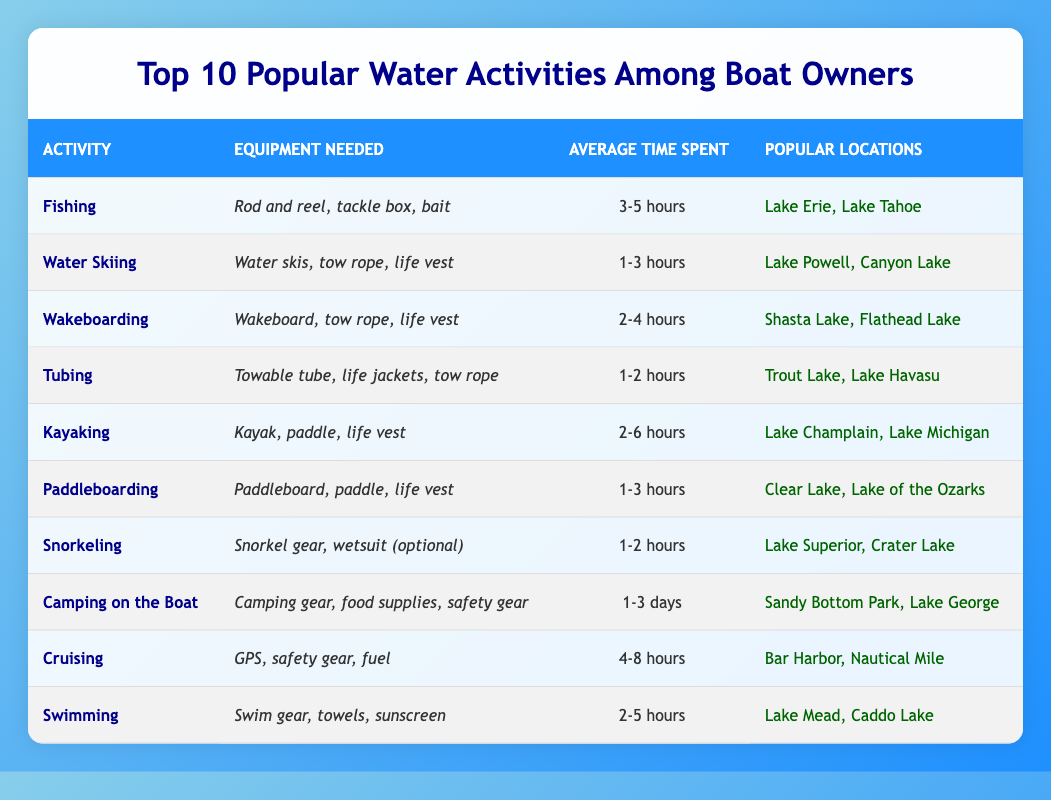What is the most time-consuming activity among boat owners? The table shows the average time spent for each activity. By comparing the values, "Camping on the Boat" has the longest average time spent of "1-3 days", making it the most time-consuming activity.
Answer: Camping on the Boat Which activity requires a towable tube? Looking at the "Equipment Needed" column, "Tubing" is the activity that specifically mentions requiring a "Towable tube".
Answer: Tubing How many activities have an average time spent of 1-3 hours? The activities listed with "average time spent" of 1-3 hours are "Water Skiing", "Paddleboarding", "Tubing", and "Camping on the Boat". Counting these gives us 4 activities.
Answer: 4 What is the equipment needed for wakeboarding? The equipment needed for "Wakeboarding" is specified in the table. It lists "Wakeboard, tow rope, life vest".
Answer: Wakeboard, tow rope, life vest Is snorkeling one of the activities with the shortest average time spent? The average time spent for "Snorkeling" is "1-2 hours". This is clearly shorter than many other activities, confirming that snorkeling is indeed one of the shortest.
Answer: Yes Which activities take between 2-5 hours on average? Checking the average time spent, the activities that fall within the 2-5 hour range are "Swimming" (2-5 hours) and "Kayaking" (2-6 hours). While Kayaking can go up to 6 hours, its minimum matches the 2-hour threshold. Thus, the confirmed range specifically applies to "Swimming".
Answer: Swimming What are the popular locations for kayaking? In the "Popular Locations" column under "Kayaking", it shows "Lake Champlain" and "Lake Michigan" as the popular locations for this activity.
Answer: Lake Champlain, Lake Michigan Which activity is the second fastest in terms of average time spent? Looking at the table, the two fastest activities in terms of time spent are "Snorkeling" (1-2 hours) and "Tubing" (1-2 hours). Since both have the same range, "Tubing" would come next for variety. However, if strictly ordered, the next distinct order will follow with Paddleboarding (1-3 hours).
Answer: Tubing Which activity involves camping gear? The activity that lists "Camping gear" in its "Equipment Needed" column is "Camping on the Boat."
Answer: Camping on the Boat Are the popular locations for cruising the same as those for water skiing? The popular locations for "Cruising" are "Bar Harbor" and "Nautical Mile", while for "Water Skiing" they are "Lake Powell" and "Canyon Lake". Since neither of these locations match, they are not the same.
Answer: No How many activities involve an average time of less than 3 hours? The activities with an average time of less than 3 hours are "Water Skiing" (1-3 hours), "Tubing" (1-2 hours), "Paddleboarding" (1-3 hours), and "Snorkeling" (1-2 hours). Counting these gives us a total of 4 activities.
Answer: 4 